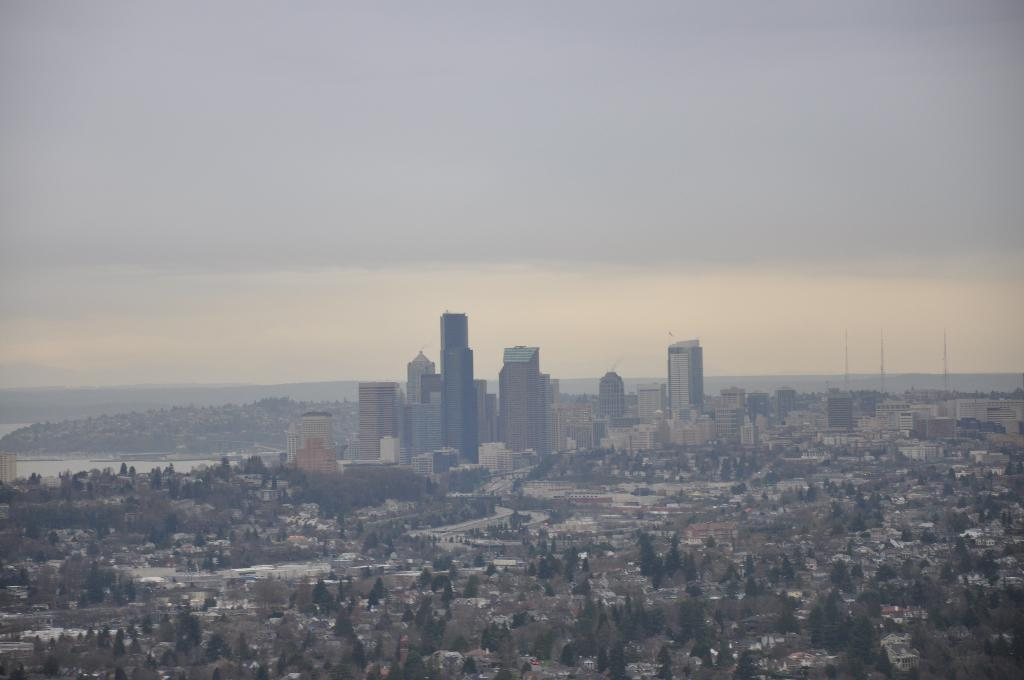What type of structures can be seen in the image? There are buildings in the image. What type of vegetation is present in the image? There are trees with green color in the image. What part of the natural environment is visible in the image? The sky is visible in the image and appears to be white. What historical event is being commemorated by the buildings in the image? There is no indication of a specific historical event being commemorated by the buildings in the image. Can you see any cellars in the image? There is no mention of cellars in the image, and they are not visible in the provided facts. 